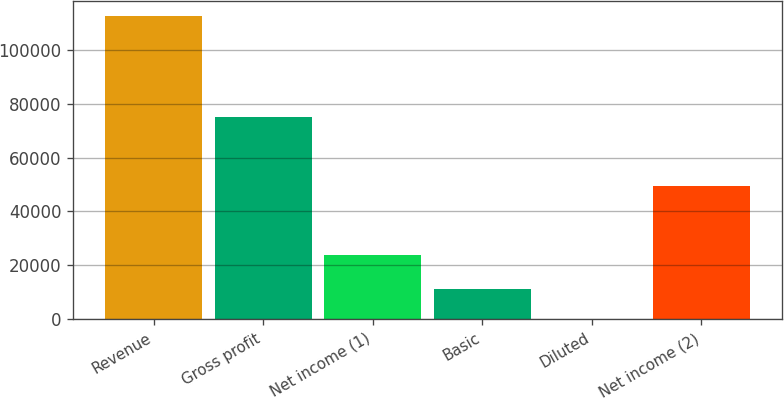Convert chart to OTSL. <chart><loc_0><loc_0><loc_500><loc_500><bar_chart><fcel>Revenue<fcel>Gross profit<fcel>Net income (1)<fcel>Basic<fcel>Diluted<fcel>Net income (2)<nl><fcel>112567<fcel>74945<fcel>23641<fcel>11257.3<fcel>0.62<fcel>49525<nl></chart> 